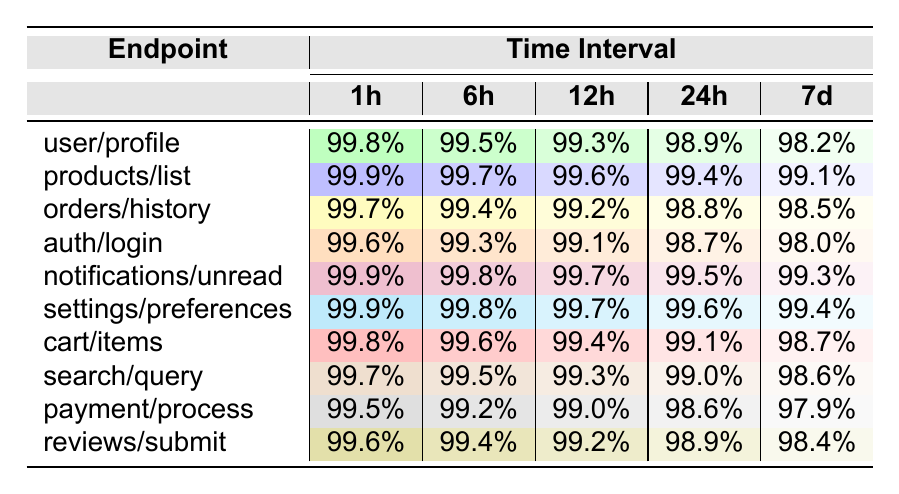What is the success rate for the 'products/list' endpoint over the last hour? The table shows the success rate for the 'products/list' endpoint in the first column and its 1h success rate is listed in the corresponding row under the 1h column. The value is 99.9%.
Answer: 99.9% Which endpoint has the lowest success rate over the 7-day period? To find the lowest success rate in the 7d column, we examine the last column of each row for all endpoints. The lowest value is 97.9% for the 'payment/process' endpoint.
Answer: payment/process What is the average success rate for the 'auth/login' endpoint? To calculate the average, we sum the success rates for 'auth/login' across all time intervals: (99.6 + 99.3 + 99.1 + 98.7 + 98.0) = 494.7. There are 5 data points, so we divide: 494.7 / 5 = 98.94%.
Answer: 98.94% Is the success rate for the 'notifications/unread' endpoint over 99% for all time intervals? We check the success rates for the 'notifications/unread' endpoint in all columns. The values are 99.9%, 99.8%, 99.7%, 99.5%, and 99.3%. All these are above 99%.
Answer: Yes Which endpoint had the most significant decrease in success rate from 1h to 7d? We need to calculate the difference between the 1h and 7d success rates for all endpoints, then find the maximum decrease. The most significant decrease is for 'auth/login': 99.6% - 98.0% = 1.6%.
Answer: auth/login What are the success rates for the 'cart/items' endpoint for the 6h and 24h intervals? Looking at the row for 'cart/items', the success rate for 6h is 99.6% and for 24h is 99.1%.
Answer: 99.6%, 99.1% Which endpoint has a success rate of 99.8% for the 1h interval? Reviewing the 1h column for each endpoint, both 'products/list' and 'notifications/unread' show a success rate of 99.9%, while 'user/profile' shows 99.8%.
Answer: user/profile What is the difference between the highest and lowest success rates for the 'search/query' endpoint? The values for the 'search/query' endpoint are 99.7% (1h) and 98.6% (7d). The difference is: 99.7% - 98.6% = 1.1%.
Answer: 1.1% Which two endpoints have the same success rate over the 12h interval? Checking the 12h column, the success rates for 'products/list' and 'orders/history' are both 99.6%.
Answer: products/list, orders/history Is there any endpoint that has a consistent success rate across all time intervals? Upon checking, no endpoint maintains the same success rate across all intervals; they all vary.
Answer: No 